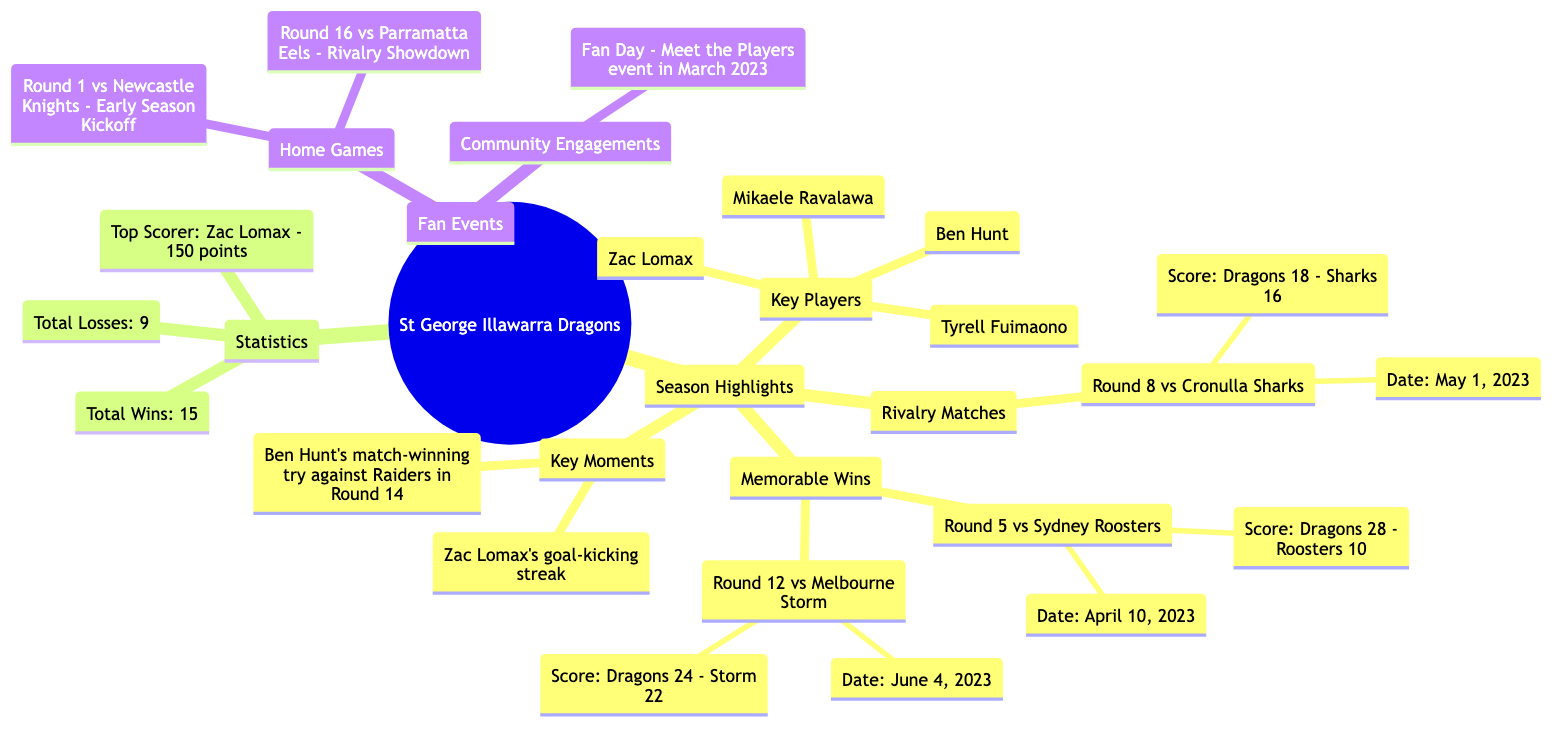What were the key players for the St. George Illawarra Dragons? There are four key players listed under Season Highlights. They are Ben Hunt, Mikaele Ravalawa, Zac Lomax, and Tyrell Fuimaono.
Answer: Ben Hunt, Mikaele Ravalawa, Zac Lomax, Tyrell Fuimaono How many memorable wins did the Dragons have? The Memorable Wins section contains two matches: Round 5 vs Sydney Roosters and Round 12 vs Melbourne Storm. Therefore, the count of memorable wins is 2.
Answer: 2 What was the date of the Round 12 match against Melbourne Storm? The diagram lists Round 12 vs Melbourne Storm under Memorable Wins with the date specified as June 4, 2023.
Answer: June 4, 2023 Who is the top scorer for the Dragons? In the Statistics section, it states that Zac Lomax is the top scorer with 150 points.
Answer: Zac Lomax What was the score of the match against the Sydney Roosters in Round 5? In the Memorable Wins section, it specifies that the score for Round 5 vs Sydney Roosters was Dragons 28 - Roosters 10.
Answer: Dragons 28 - Roosters 10 Which round featured a rivalry match against the Cronulla Sharks? The Rivalry Matches section indicates that the match against the Cronulla Sharks occurred in Round 8.
Answer: Round 8 What notable event occurred in March 2023? The Fan Events section highlights a Community Engagement called Fan Day, which was a Meet the Players event that took place in March 2023.
Answer: Fan Day - Meet the Players event Why is Ben Hunt mentioned as a key moment? Under Key Moments, it is stated that Ben Hunt scored a match-winning try against the Raiders in Round 14, highlighting his significance in that moment.
Answer: Match-winning try against the Raiders in Round 14 How many total losses did the Dragons have in the season? The Statistics section explicitly mentions the total losses as 9.
Answer: 9 